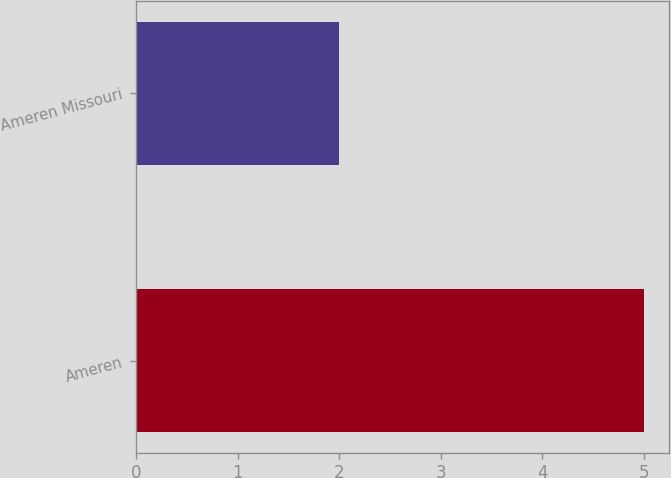Convert chart to OTSL. <chart><loc_0><loc_0><loc_500><loc_500><bar_chart><fcel>Ameren<fcel>Ameren Missouri<nl><fcel>5<fcel>2<nl></chart> 